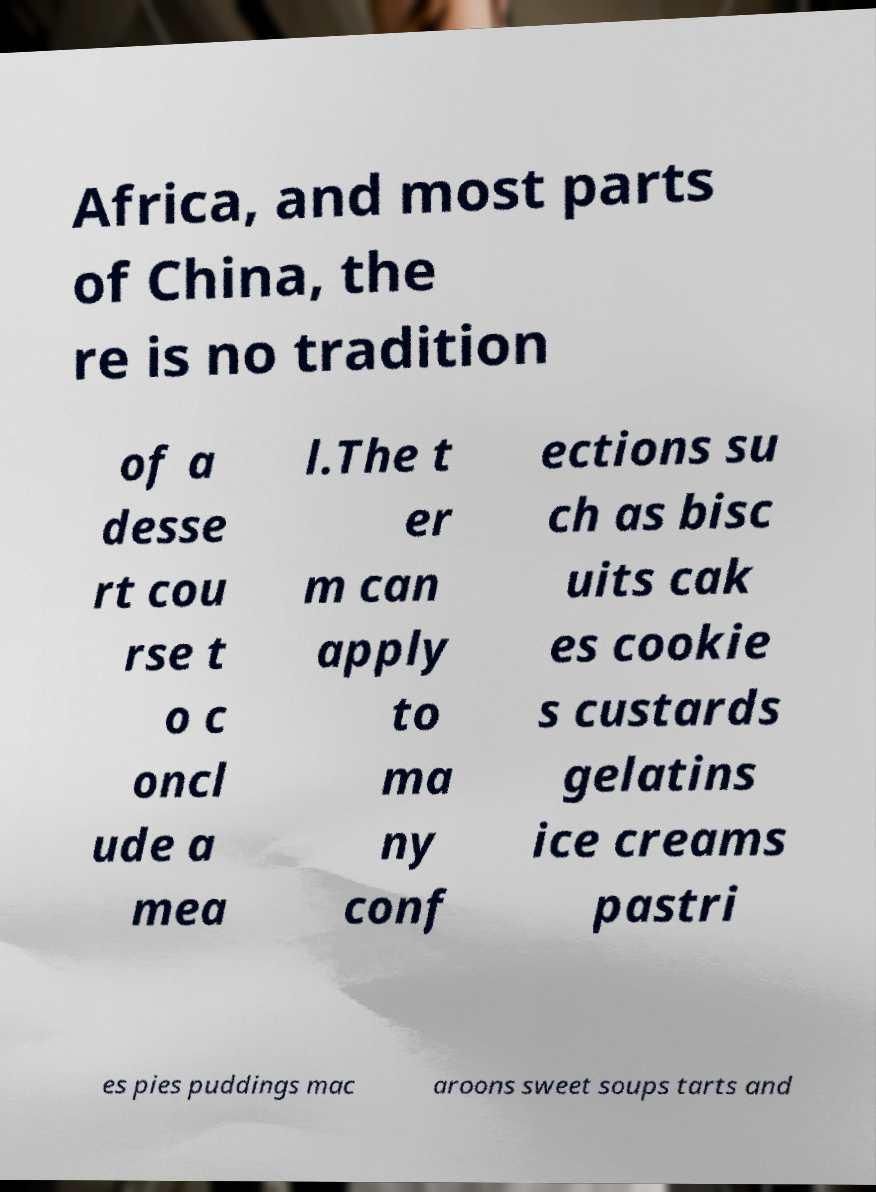Please read and relay the text visible in this image. What does it say? Africa, and most parts of China, the re is no tradition of a desse rt cou rse t o c oncl ude a mea l.The t er m can apply to ma ny conf ections su ch as bisc uits cak es cookie s custards gelatins ice creams pastri es pies puddings mac aroons sweet soups tarts and 